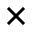Convert formula to latex. <formula><loc_0><loc_0><loc_500><loc_500>\times</formula> 